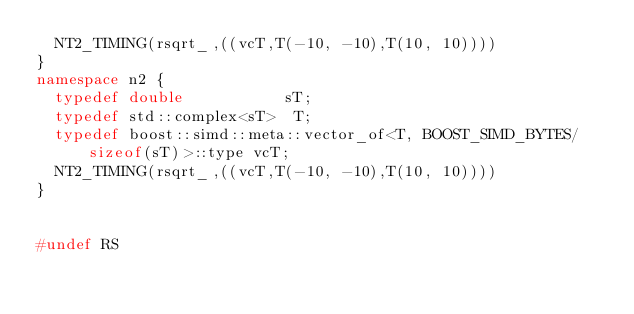Convert code to text. <code><loc_0><loc_0><loc_500><loc_500><_C++_>  NT2_TIMING(rsqrt_,((vcT,T(-10, -10),T(10, 10))))
}
namespace n2 {
  typedef double           sT;
  typedef std::complex<sT>  T;
  typedef boost::simd::meta::vector_of<T, BOOST_SIMD_BYTES/sizeof(sT)>::type vcT;
  NT2_TIMING(rsqrt_,((vcT,T(-10, -10),T(10, 10))))
}


#undef RS
</code> 